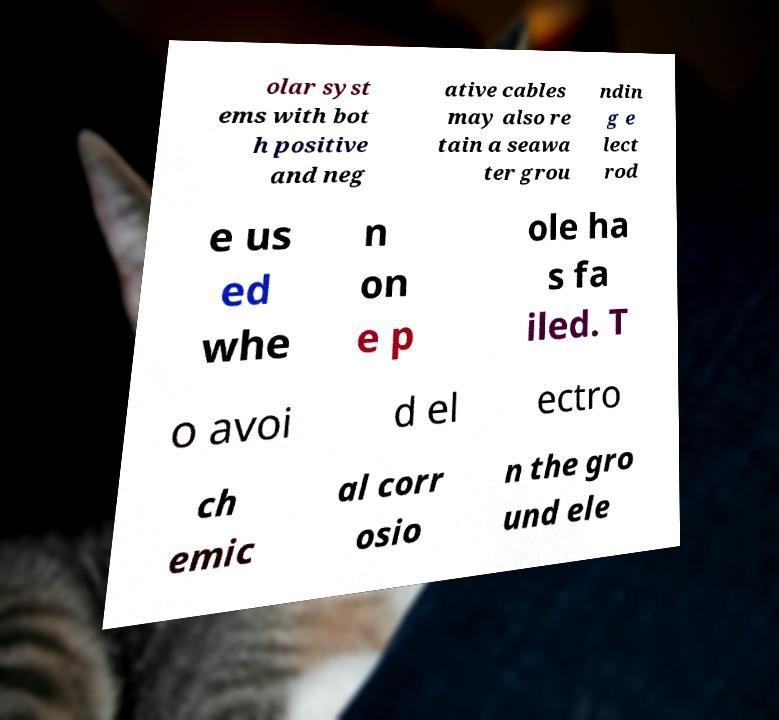For documentation purposes, I need the text within this image transcribed. Could you provide that? olar syst ems with bot h positive and neg ative cables may also re tain a seawa ter grou ndin g e lect rod e us ed whe n on e p ole ha s fa iled. T o avoi d el ectro ch emic al corr osio n the gro und ele 